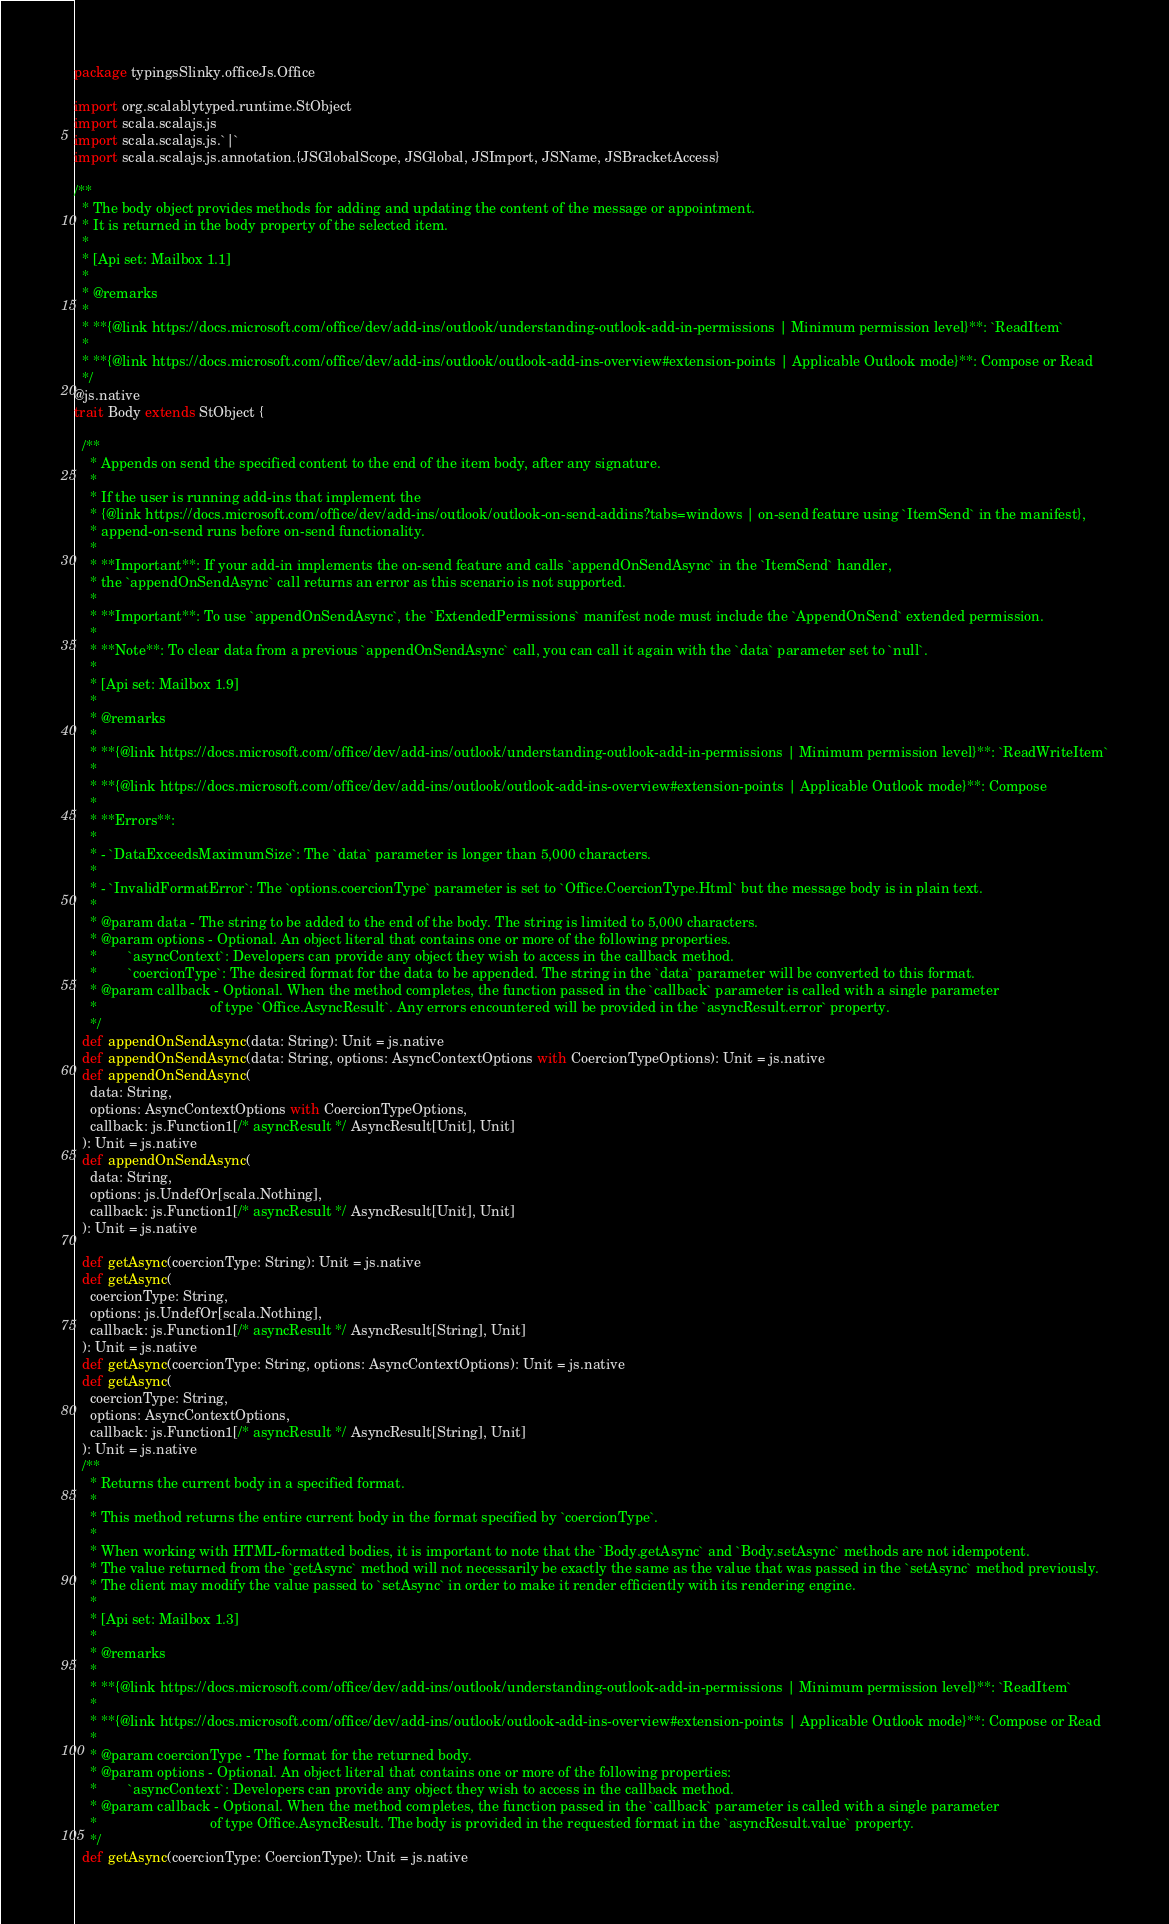Convert code to text. <code><loc_0><loc_0><loc_500><loc_500><_Scala_>package typingsSlinky.officeJs.Office

import org.scalablytyped.runtime.StObject
import scala.scalajs.js
import scala.scalajs.js.`|`
import scala.scalajs.js.annotation.{JSGlobalScope, JSGlobal, JSImport, JSName, JSBracketAccess}

/**
  * The body object provides methods for adding and updating the content of the message or appointment. 
  * It is returned in the body property of the selected item.
  *
  * [Api set: Mailbox 1.1]
  *
  * @remarks
  * 
  * **{@link https://docs.microsoft.com/office/dev/add-ins/outlook/understanding-outlook-add-in-permissions | Minimum permission level}**: `ReadItem`
  * 
  * **{@link https://docs.microsoft.com/office/dev/add-ins/outlook/outlook-add-ins-overview#extension-points | Applicable Outlook mode}**: Compose or Read
  */
@js.native
trait Body extends StObject {
  
  /**
    * Appends on send the specified content to the end of the item body, after any signature.
    *
    * If the user is running add-ins that implement the
    * {@link https://docs.microsoft.com/office/dev/add-ins/outlook/outlook-on-send-addins?tabs=windows | on-send feature using `ItemSend` in the manifest},
    * append-on-send runs before on-send functionality.
    *
    * **Important**: If your add-in implements the on-send feature and calls `appendOnSendAsync` in the `ItemSend` handler,
    * the `appendOnSendAsync` call returns an error as this scenario is not supported.
    *
    * **Important**: To use `appendOnSendAsync`, the `ExtendedPermissions` manifest node must include the `AppendOnSend` extended permission.
    *
    * **Note**: To clear data from a previous `appendOnSendAsync` call, you can call it again with the `data` parameter set to `null`.
    *
    * [Api set: Mailbox 1.9]
    *
    * @remarks
    *
    * **{@link https://docs.microsoft.com/office/dev/add-ins/outlook/understanding-outlook-add-in-permissions | Minimum permission level}**: `ReadWriteItem`
    *
    * **{@link https://docs.microsoft.com/office/dev/add-ins/outlook/outlook-add-ins-overview#extension-points | Applicable Outlook mode}**: Compose
    *
    * **Errors**:
    *
    * - `DataExceedsMaximumSize`: The `data` parameter is longer than 5,000 characters.
    *
    * - `InvalidFormatError`: The `options.coercionType` parameter is set to `Office.CoercionType.Html` but the message body is in plain text.
    *
    * @param data - The string to be added to the end of the body. The string is limited to 5,000 characters.
    * @param options - Optional. An object literal that contains one or more of the following properties.
    *        `asyncContext`: Developers can provide any object they wish to access in the callback method.
    *        `coercionType`: The desired format for the data to be appended. The string in the `data` parameter will be converted to this format.
    * @param callback - Optional. When the method completes, the function passed in the `callback` parameter is called with a single parameter
    *                             of type `Office.AsyncResult`. Any errors encountered will be provided in the `asyncResult.error` property.
    */
  def appendOnSendAsync(data: String): Unit = js.native
  def appendOnSendAsync(data: String, options: AsyncContextOptions with CoercionTypeOptions): Unit = js.native
  def appendOnSendAsync(
    data: String,
    options: AsyncContextOptions with CoercionTypeOptions,
    callback: js.Function1[/* asyncResult */ AsyncResult[Unit], Unit]
  ): Unit = js.native
  def appendOnSendAsync(
    data: String,
    options: js.UndefOr[scala.Nothing],
    callback: js.Function1[/* asyncResult */ AsyncResult[Unit], Unit]
  ): Unit = js.native
  
  def getAsync(coercionType: String): Unit = js.native
  def getAsync(
    coercionType: String,
    options: js.UndefOr[scala.Nothing],
    callback: js.Function1[/* asyncResult */ AsyncResult[String], Unit]
  ): Unit = js.native
  def getAsync(coercionType: String, options: AsyncContextOptions): Unit = js.native
  def getAsync(
    coercionType: String,
    options: AsyncContextOptions,
    callback: js.Function1[/* asyncResult */ AsyncResult[String], Unit]
  ): Unit = js.native
  /**
    * Returns the current body in a specified format.
    *
    * This method returns the entire current body in the format specified by `coercionType`.
    *
    * When working with HTML-formatted bodies, it is important to note that the `Body.getAsync` and `Body.setAsync` methods are not idempotent.
    * The value returned from the `getAsync` method will not necessarily be exactly the same as the value that was passed in the `setAsync` method previously. 
    * The client may modify the value passed to `setAsync` in order to make it render efficiently with its rendering engine.
    *
    * [Api set: Mailbox 1.3]
    *
    * @remarks
    * 
    * **{@link https://docs.microsoft.com/office/dev/add-ins/outlook/understanding-outlook-add-in-permissions | Minimum permission level}**: `ReadItem`
    * 
    * **{@link https://docs.microsoft.com/office/dev/add-ins/outlook/outlook-add-ins-overview#extension-points | Applicable Outlook mode}**: Compose or Read
    * 
    * @param coercionType - The format for the returned body.
    * @param options - Optional. An object literal that contains one or more of the following properties:
    *        `asyncContext`: Developers can provide any object they wish to access in the callback method.
    * @param callback - Optional. When the method completes, the function passed in the `callback` parameter is called with a single parameter
    *                             of type Office.AsyncResult. The body is provided in the requested format in the `asyncResult.value` property.
    */
  def getAsync(coercionType: CoercionType): Unit = js.native</code> 